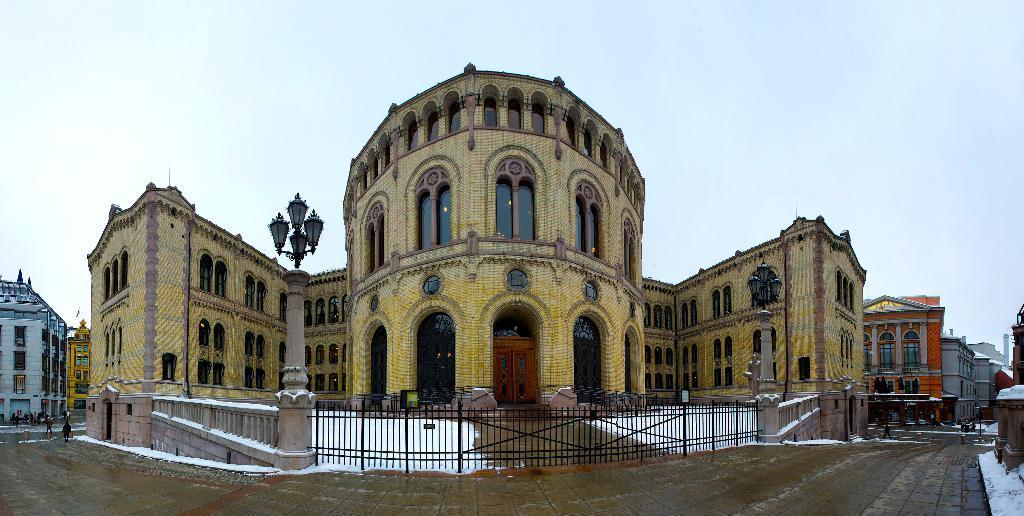Please provide a concise description of this image. In the center of the image we can see a buildings, lights, grills are present. At the bottom of the image ground is there. At the top of the image sky is present. On the left side of the image some persons are there. 